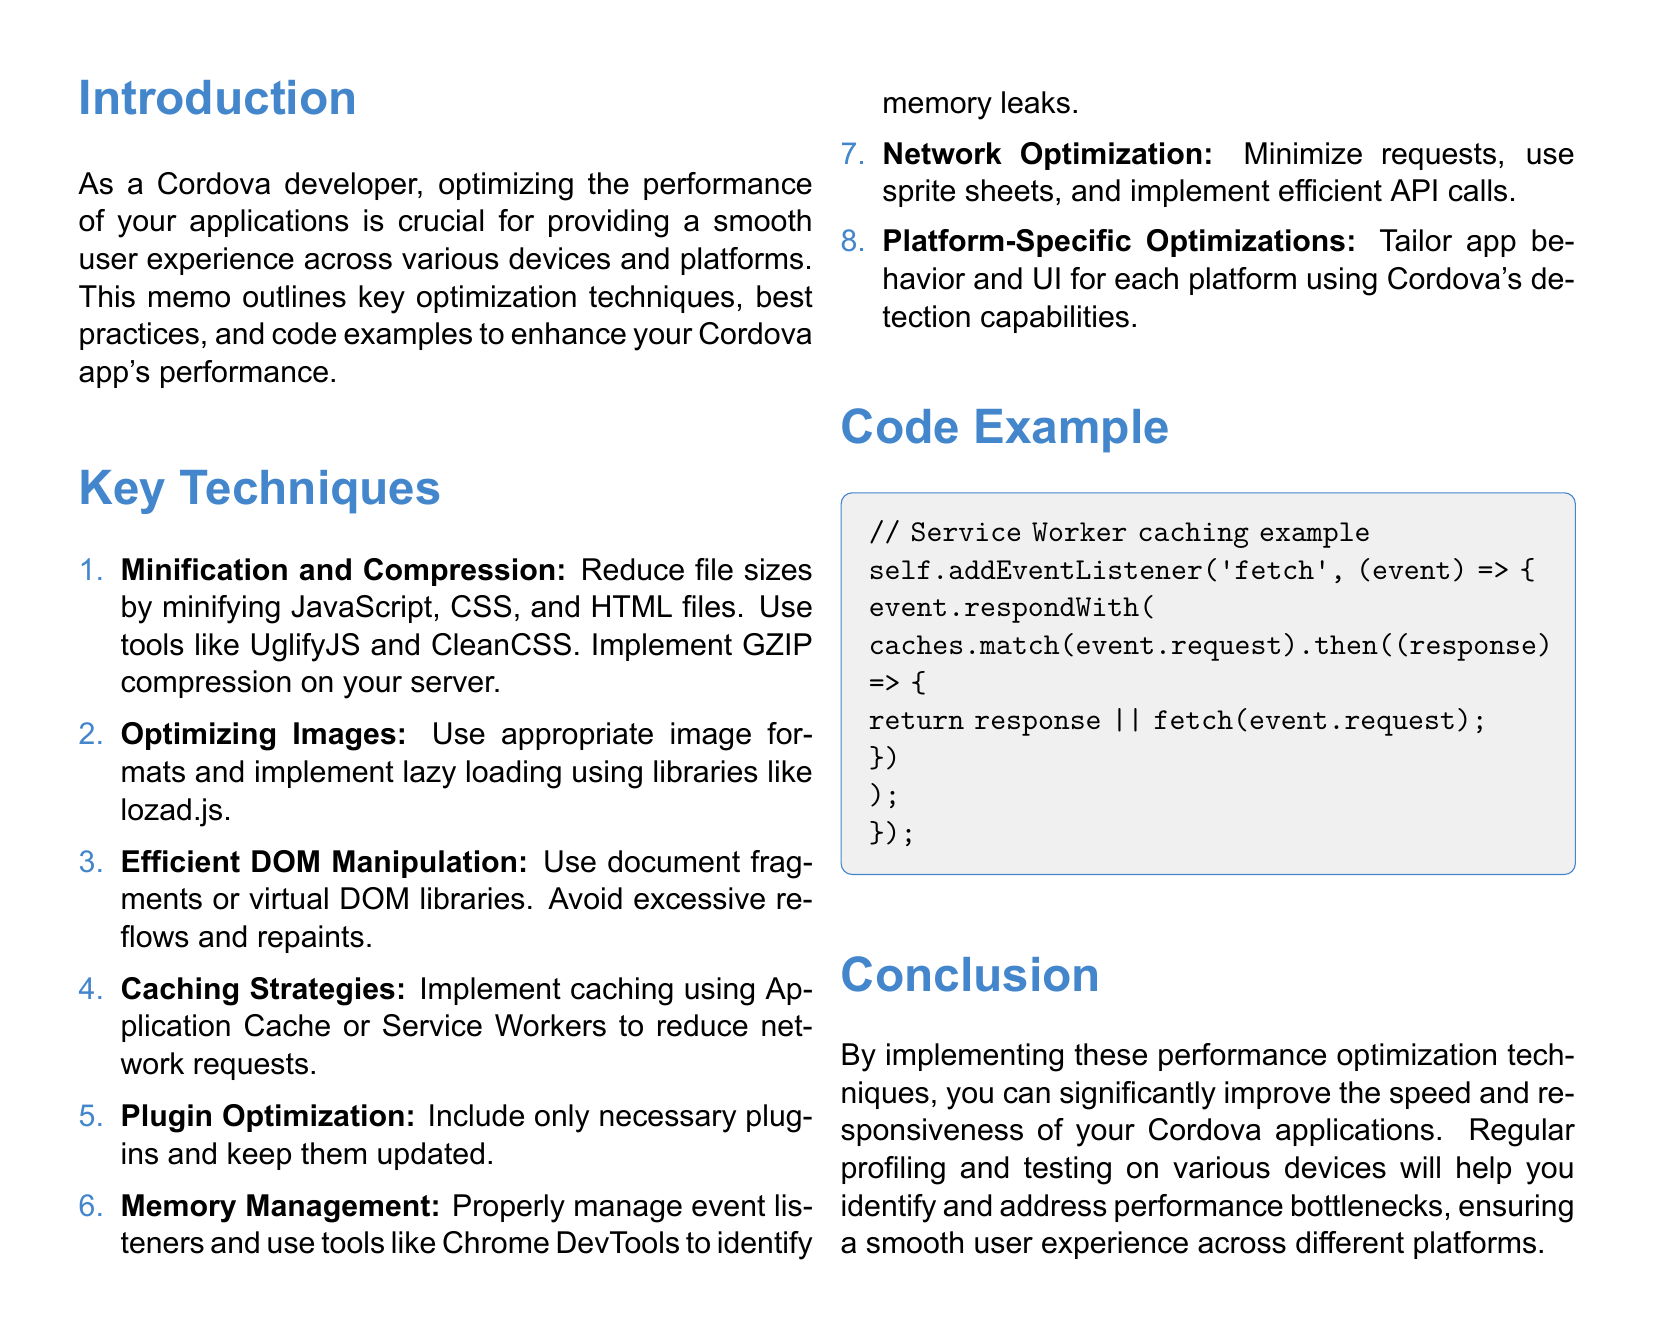What is the title of the document? The title is explicitly stated at the beginning of the document.
Answer: Performance Optimization Techniques for Cordova Applications How many key techniques are outlined in the document? The number of key techniques is mentioned in the enumeration section.
Answer: Eight Which tool is recommended for minifying JavaScript files? The document specifies UglifyJS as a tool for this purpose.
Answer: UglifyJS What is one recommended strategy for optimizing images? The document mentions using appropriate image formats and lazy loading as optimization strategies.
Answer: Lazy loading What should developers remove to reduce app size? The document highlights the importance of only including necessary elements in the project to manage size.
Answer: Unused plugins Which event management practice is emphasized for memory management? The document outlines proper handling of event listeners.
Answer: Removing event listeners Which API can be used to adapt app behavior based on network conditions? The document specifically mentions the Network Information API for this adaptation.
Answer: Network Information API What was the conclusion regarding performance optimization techniques? The conclusion summarizes the impact of performance optimizations on application speed and responsiveness.
Answer: Improve speed and responsiveness 